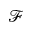<formula> <loc_0><loc_0><loc_500><loc_500>\mathcal { F }</formula> 